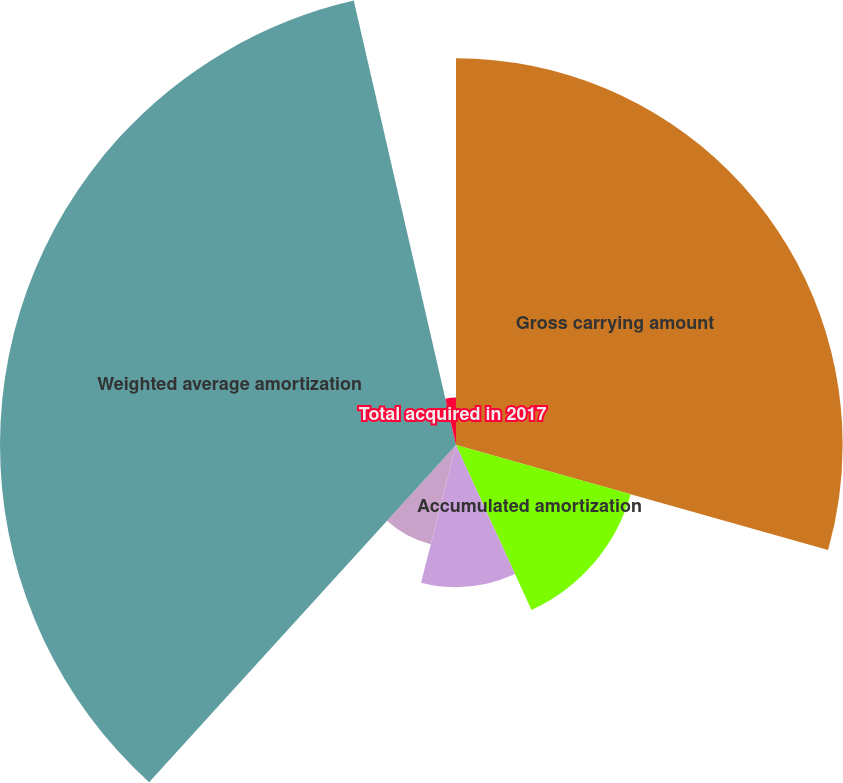<chart> <loc_0><loc_0><loc_500><loc_500><pie_chart><fcel>Gross carrying amount<fcel>Accumulated amortization<fcel>Net other intangibles as of<fcel>Total acquired in 2018<fcel>Weighted average amortization<fcel>Total acquired in 2017<nl><fcel>29.38%<fcel>13.79%<fcel>10.79%<fcel>7.79%<fcel>34.65%<fcel>3.6%<nl></chart> 